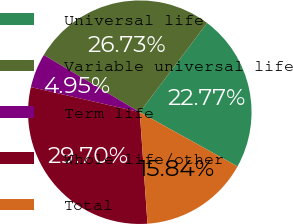Convert chart to OTSL. <chart><loc_0><loc_0><loc_500><loc_500><pie_chart><fcel>Universal life<fcel>Variable universal life<fcel>Term life<fcel>Whole life/other<fcel>Total<nl><fcel>22.77%<fcel>26.73%<fcel>4.95%<fcel>29.7%<fcel>15.84%<nl></chart> 